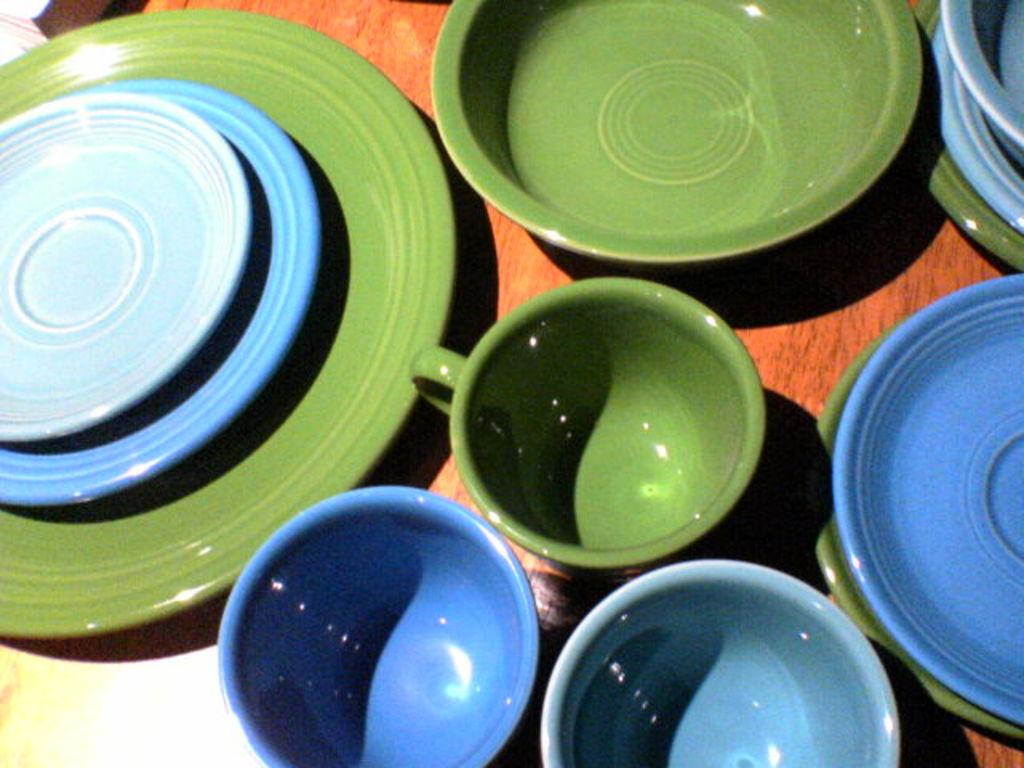What type of objects are on the wooden surface in the image? There are cups, plates, and bowls on the wooden surface. Can you describe the material of the surface? The surface is made of wood. How many types of objects can be seen on the wooden surface? There are three types of objects: cups, plates, and bowls. What type of hill can be seen in the background of the image? There is no hill visible in the image; it only shows cups, plates, and bowls on a wooden surface. 